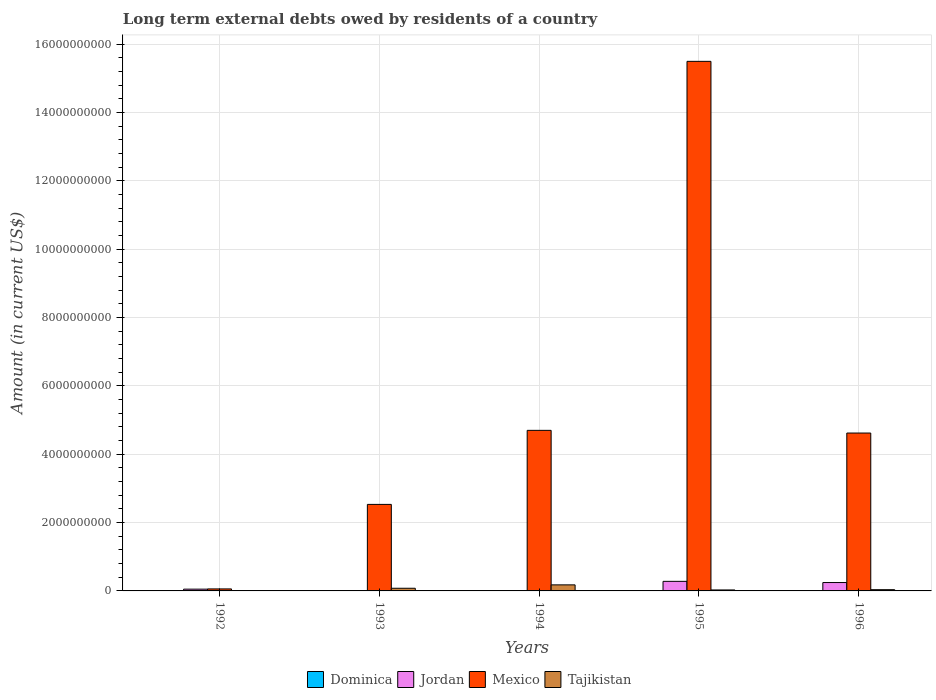Are the number of bars per tick equal to the number of legend labels?
Your answer should be compact. No. Are the number of bars on each tick of the X-axis equal?
Keep it short and to the point. No. How many bars are there on the 5th tick from the left?
Offer a very short reply. 4. How many bars are there on the 1st tick from the right?
Your answer should be very brief. 4. In how many cases, is the number of bars for a given year not equal to the number of legend labels?
Give a very brief answer. 2. What is the amount of long-term external debts owed by residents in Dominica in 1993?
Your response must be concise. 1.93e+06. Across all years, what is the maximum amount of long-term external debts owed by residents in Jordan?
Give a very brief answer. 2.80e+08. Across all years, what is the minimum amount of long-term external debts owed by residents in Jordan?
Provide a short and direct response. 0. In which year was the amount of long-term external debts owed by residents in Tajikistan maximum?
Give a very brief answer. 1994. What is the total amount of long-term external debts owed by residents in Tajikistan in the graph?
Offer a terse response. 3.30e+08. What is the difference between the amount of long-term external debts owed by residents in Dominica in 1992 and that in 1993?
Your response must be concise. 3.82e+06. What is the difference between the amount of long-term external debts owed by residents in Mexico in 1994 and the amount of long-term external debts owed by residents in Jordan in 1995?
Ensure brevity in your answer.  4.42e+09. What is the average amount of long-term external debts owed by residents in Dominica per year?
Provide a succinct answer. 3.55e+06. In the year 1992, what is the difference between the amount of long-term external debts owed by residents in Tajikistan and amount of long-term external debts owed by residents in Jordan?
Provide a short and direct response. -4.21e+07. In how many years, is the amount of long-term external debts owed by residents in Dominica greater than 10800000000 US$?
Offer a terse response. 0. What is the ratio of the amount of long-term external debts owed by residents in Dominica in 1993 to that in 1996?
Your answer should be very brief. 0.45. Is the amount of long-term external debts owed by residents in Tajikistan in 1994 less than that in 1996?
Offer a terse response. No. What is the difference between the highest and the second highest amount of long-term external debts owed by residents in Jordan?
Provide a short and direct response. 3.48e+07. What is the difference between the highest and the lowest amount of long-term external debts owed by residents in Mexico?
Make the answer very short. 1.54e+1. Is it the case that in every year, the sum of the amount of long-term external debts owed by residents in Tajikistan and amount of long-term external debts owed by residents in Mexico is greater than the sum of amount of long-term external debts owed by residents in Jordan and amount of long-term external debts owed by residents in Dominica?
Keep it short and to the point. No. Is it the case that in every year, the sum of the amount of long-term external debts owed by residents in Jordan and amount of long-term external debts owed by residents in Tajikistan is greater than the amount of long-term external debts owed by residents in Mexico?
Offer a terse response. No. How many bars are there?
Your answer should be compact. 17. Are the values on the major ticks of Y-axis written in scientific E-notation?
Make the answer very short. No. Does the graph contain any zero values?
Ensure brevity in your answer.  Yes. Where does the legend appear in the graph?
Provide a succinct answer. Bottom center. How many legend labels are there?
Your response must be concise. 4. What is the title of the graph?
Your response must be concise. Long term external debts owed by residents of a country. Does "United Kingdom" appear as one of the legend labels in the graph?
Offer a very short reply. No. What is the label or title of the Y-axis?
Ensure brevity in your answer.  Amount (in current US$). What is the Amount (in current US$) of Dominica in 1992?
Your answer should be compact. 5.75e+06. What is the Amount (in current US$) of Jordan in 1992?
Offer a terse response. 5.19e+07. What is the Amount (in current US$) of Mexico in 1992?
Offer a very short reply. 5.86e+07. What is the Amount (in current US$) of Tajikistan in 1992?
Give a very brief answer. 9.73e+06. What is the Amount (in current US$) of Dominica in 1993?
Keep it short and to the point. 1.93e+06. What is the Amount (in current US$) of Jordan in 1993?
Your answer should be very brief. 0. What is the Amount (in current US$) of Mexico in 1993?
Keep it short and to the point. 2.53e+09. What is the Amount (in current US$) of Tajikistan in 1993?
Give a very brief answer. 7.82e+07. What is the Amount (in current US$) of Dominica in 1994?
Keep it short and to the point. 0. What is the Amount (in current US$) in Jordan in 1994?
Make the answer very short. 0. What is the Amount (in current US$) of Mexico in 1994?
Offer a very short reply. 4.70e+09. What is the Amount (in current US$) in Tajikistan in 1994?
Provide a short and direct response. 1.77e+08. What is the Amount (in current US$) of Dominica in 1995?
Make the answer very short. 5.77e+06. What is the Amount (in current US$) in Jordan in 1995?
Provide a succinct answer. 2.80e+08. What is the Amount (in current US$) of Mexico in 1995?
Offer a terse response. 1.55e+1. What is the Amount (in current US$) in Tajikistan in 1995?
Your response must be concise. 2.84e+07. What is the Amount (in current US$) of Dominica in 1996?
Make the answer very short. 4.31e+06. What is the Amount (in current US$) of Jordan in 1996?
Give a very brief answer. 2.45e+08. What is the Amount (in current US$) of Mexico in 1996?
Ensure brevity in your answer.  4.62e+09. What is the Amount (in current US$) in Tajikistan in 1996?
Your answer should be compact. 3.65e+07. Across all years, what is the maximum Amount (in current US$) in Dominica?
Offer a terse response. 5.77e+06. Across all years, what is the maximum Amount (in current US$) of Jordan?
Ensure brevity in your answer.  2.80e+08. Across all years, what is the maximum Amount (in current US$) of Mexico?
Offer a terse response. 1.55e+1. Across all years, what is the maximum Amount (in current US$) of Tajikistan?
Make the answer very short. 1.77e+08. Across all years, what is the minimum Amount (in current US$) of Mexico?
Offer a terse response. 5.86e+07. Across all years, what is the minimum Amount (in current US$) in Tajikistan?
Offer a terse response. 9.73e+06. What is the total Amount (in current US$) in Dominica in the graph?
Your response must be concise. 1.78e+07. What is the total Amount (in current US$) in Jordan in the graph?
Give a very brief answer. 5.78e+08. What is the total Amount (in current US$) in Mexico in the graph?
Your answer should be compact. 2.74e+1. What is the total Amount (in current US$) of Tajikistan in the graph?
Ensure brevity in your answer.  3.30e+08. What is the difference between the Amount (in current US$) in Dominica in 1992 and that in 1993?
Provide a succinct answer. 3.82e+06. What is the difference between the Amount (in current US$) of Mexico in 1992 and that in 1993?
Offer a terse response. -2.47e+09. What is the difference between the Amount (in current US$) in Tajikistan in 1992 and that in 1993?
Ensure brevity in your answer.  -6.84e+07. What is the difference between the Amount (in current US$) of Mexico in 1992 and that in 1994?
Your answer should be very brief. -4.64e+09. What is the difference between the Amount (in current US$) in Tajikistan in 1992 and that in 1994?
Provide a short and direct response. -1.67e+08. What is the difference between the Amount (in current US$) of Dominica in 1992 and that in 1995?
Make the answer very short. -1.50e+04. What is the difference between the Amount (in current US$) of Jordan in 1992 and that in 1995?
Your answer should be compact. -2.28e+08. What is the difference between the Amount (in current US$) of Mexico in 1992 and that in 1995?
Offer a terse response. -1.54e+1. What is the difference between the Amount (in current US$) of Tajikistan in 1992 and that in 1995?
Provide a succinct answer. -1.86e+07. What is the difference between the Amount (in current US$) of Dominica in 1992 and that in 1996?
Make the answer very short. 1.44e+06. What is the difference between the Amount (in current US$) of Jordan in 1992 and that in 1996?
Keep it short and to the point. -1.94e+08. What is the difference between the Amount (in current US$) in Mexico in 1992 and that in 1996?
Your response must be concise. -4.56e+09. What is the difference between the Amount (in current US$) of Tajikistan in 1992 and that in 1996?
Ensure brevity in your answer.  -2.68e+07. What is the difference between the Amount (in current US$) in Mexico in 1993 and that in 1994?
Your answer should be compact. -2.17e+09. What is the difference between the Amount (in current US$) in Tajikistan in 1993 and that in 1994?
Give a very brief answer. -9.89e+07. What is the difference between the Amount (in current US$) in Dominica in 1993 and that in 1995?
Provide a succinct answer. -3.84e+06. What is the difference between the Amount (in current US$) of Mexico in 1993 and that in 1995?
Ensure brevity in your answer.  -1.30e+1. What is the difference between the Amount (in current US$) in Tajikistan in 1993 and that in 1995?
Provide a short and direct response. 4.98e+07. What is the difference between the Amount (in current US$) in Dominica in 1993 and that in 1996?
Provide a short and direct response. -2.38e+06. What is the difference between the Amount (in current US$) in Mexico in 1993 and that in 1996?
Give a very brief answer. -2.09e+09. What is the difference between the Amount (in current US$) of Tajikistan in 1993 and that in 1996?
Offer a terse response. 4.17e+07. What is the difference between the Amount (in current US$) of Mexico in 1994 and that in 1995?
Provide a short and direct response. -1.08e+1. What is the difference between the Amount (in current US$) in Tajikistan in 1994 and that in 1995?
Make the answer very short. 1.49e+08. What is the difference between the Amount (in current US$) of Mexico in 1994 and that in 1996?
Offer a terse response. 7.86e+07. What is the difference between the Amount (in current US$) of Tajikistan in 1994 and that in 1996?
Give a very brief answer. 1.41e+08. What is the difference between the Amount (in current US$) in Dominica in 1995 and that in 1996?
Keep it short and to the point. 1.46e+06. What is the difference between the Amount (in current US$) in Jordan in 1995 and that in 1996?
Give a very brief answer. 3.48e+07. What is the difference between the Amount (in current US$) in Mexico in 1995 and that in 1996?
Ensure brevity in your answer.  1.09e+1. What is the difference between the Amount (in current US$) of Tajikistan in 1995 and that in 1996?
Your answer should be compact. -8.11e+06. What is the difference between the Amount (in current US$) of Dominica in 1992 and the Amount (in current US$) of Mexico in 1993?
Provide a succinct answer. -2.53e+09. What is the difference between the Amount (in current US$) in Dominica in 1992 and the Amount (in current US$) in Tajikistan in 1993?
Offer a very short reply. -7.24e+07. What is the difference between the Amount (in current US$) in Jordan in 1992 and the Amount (in current US$) in Mexico in 1993?
Provide a succinct answer. -2.48e+09. What is the difference between the Amount (in current US$) in Jordan in 1992 and the Amount (in current US$) in Tajikistan in 1993?
Provide a short and direct response. -2.63e+07. What is the difference between the Amount (in current US$) of Mexico in 1992 and the Amount (in current US$) of Tajikistan in 1993?
Keep it short and to the point. -1.96e+07. What is the difference between the Amount (in current US$) of Dominica in 1992 and the Amount (in current US$) of Mexico in 1994?
Provide a short and direct response. -4.69e+09. What is the difference between the Amount (in current US$) of Dominica in 1992 and the Amount (in current US$) of Tajikistan in 1994?
Your response must be concise. -1.71e+08. What is the difference between the Amount (in current US$) of Jordan in 1992 and the Amount (in current US$) of Mexico in 1994?
Provide a short and direct response. -4.65e+09. What is the difference between the Amount (in current US$) of Jordan in 1992 and the Amount (in current US$) of Tajikistan in 1994?
Offer a very short reply. -1.25e+08. What is the difference between the Amount (in current US$) of Mexico in 1992 and the Amount (in current US$) of Tajikistan in 1994?
Give a very brief answer. -1.19e+08. What is the difference between the Amount (in current US$) in Dominica in 1992 and the Amount (in current US$) in Jordan in 1995?
Keep it short and to the point. -2.75e+08. What is the difference between the Amount (in current US$) in Dominica in 1992 and the Amount (in current US$) in Mexico in 1995?
Provide a succinct answer. -1.55e+1. What is the difference between the Amount (in current US$) of Dominica in 1992 and the Amount (in current US$) of Tajikistan in 1995?
Give a very brief answer. -2.26e+07. What is the difference between the Amount (in current US$) of Jordan in 1992 and the Amount (in current US$) of Mexico in 1995?
Offer a very short reply. -1.54e+1. What is the difference between the Amount (in current US$) in Jordan in 1992 and the Amount (in current US$) in Tajikistan in 1995?
Your answer should be compact. 2.35e+07. What is the difference between the Amount (in current US$) of Mexico in 1992 and the Amount (in current US$) of Tajikistan in 1995?
Your response must be concise. 3.02e+07. What is the difference between the Amount (in current US$) in Dominica in 1992 and the Amount (in current US$) in Jordan in 1996?
Make the answer very short. -2.40e+08. What is the difference between the Amount (in current US$) in Dominica in 1992 and the Amount (in current US$) in Mexico in 1996?
Offer a terse response. -4.61e+09. What is the difference between the Amount (in current US$) in Dominica in 1992 and the Amount (in current US$) in Tajikistan in 1996?
Keep it short and to the point. -3.07e+07. What is the difference between the Amount (in current US$) of Jordan in 1992 and the Amount (in current US$) of Mexico in 1996?
Ensure brevity in your answer.  -4.57e+09. What is the difference between the Amount (in current US$) in Jordan in 1992 and the Amount (in current US$) in Tajikistan in 1996?
Keep it short and to the point. 1.54e+07. What is the difference between the Amount (in current US$) in Mexico in 1992 and the Amount (in current US$) in Tajikistan in 1996?
Keep it short and to the point. 2.21e+07. What is the difference between the Amount (in current US$) of Dominica in 1993 and the Amount (in current US$) of Mexico in 1994?
Your answer should be compact. -4.70e+09. What is the difference between the Amount (in current US$) of Dominica in 1993 and the Amount (in current US$) of Tajikistan in 1994?
Offer a very short reply. -1.75e+08. What is the difference between the Amount (in current US$) of Mexico in 1993 and the Amount (in current US$) of Tajikistan in 1994?
Your response must be concise. 2.36e+09. What is the difference between the Amount (in current US$) in Dominica in 1993 and the Amount (in current US$) in Jordan in 1995?
Provide a succinct answer. -2.78e+08. What is the difference between the Amount (in current US$) in Dominica in 1993 and the Amount (in current US$) in Mexico in 1995?
Offer a terse response. -1.55e+1. What is the difference between the Amount (in current US$) in Dominica in 1993 and the Amount (in current US$) in Tajikistan in 1995?
Provide a short and direct response. -2.64e+07. What is the difference between the Amount (in current US$) in Mexico in 1993 and the Amount (in current US$) in Tajikistan in 1995?
Provide a succinct answer. 2.50e+09. What is the difference between the Amount (in current US$) in Dominica in 1993 and the Amount (in current US$) in Jordan in 1996?
Give a very brief answer. -2.44e+08. What is the difference between the Amount (in current US$) of Dominica in 1993 and the Amount (in current US$) of Mexico in 1996?
Provide a succinct answer. -4.62e+09. What is the difference between the Amount (in current US$) in Dominica in 1993 and the Amount (in current US$) in Tajikistan in 1996?
Offer a terse response. -3.46e+07. What is the difference between the Amount (in current US$) in Mexico in 1993 and the Amount (in current US$) in Tajikistan in 1996?
Your answer should be very brief. 2.50e+09. What is the difference between the Amount (in current US$) of Mexico in 1994 and the Amount (in current US$) of Tajikistan in 1995?
Your response must be concise. 4.67e+09. What is the difference between the Amount (in current US$) of Mexico in 1994 and the Amount (in current US$) of Tajikistan in 1996?
Ensure brevity in your answer.  4.66e+09. What is the difference between the Amount (in current US$) in Dominica in 1995 and the Amount (in current US$) in Jordan in 1996?
Provide a short and direct response. -2.40e+08. What is the difference between the Amount (in current US$) of Dominica in 1995 and the Amount (in current US$) of Mexico in 1996?
Keep it short and to the point. -4.61e+09. What is the difference between the Amount (in current US$) in Dominica in 1995 and the Amount (in current US$) in Tajikistan in 1996?
Ensure brevity in your answer.  -3.07e+07. What is the difference between the Amount (in current US$) in Jordan in 1995 and the Amount (in current US$) in Mexico in 1996?
Make the answer very short. -4.34e+09. What is the difference between the Amount (in current US$) in Jordan in 1995 and the Amount (in current US$) in Tajikistan in 1996?
Offer a very short reply. 2.44e+08. What is the difference between the Amount (in current US$) in Mexico in 1995 and the Amount (in current US$) in Tajikistan in 1996?
Keep it short and to the point. 1.55e+1. What is the average Amount (in current US$) in Dominica per year?
Make the answer very short. 3.55e+06. What is the average Amount (in current US$) of Jordan per year?
Ensure brevity in your answer.  1.16e+08. What is the average Amount (in current US$) of Mexico per year?
Provide a short and direct response. 5.48e+09. What is the average Amount (in current US$) of Tajikistan per year?
Offer a terse response. 6.60e+07. In the year 1992, what is the difference between the Amount (in current US$) in Dominica and Amount (in current US$) in Jordan?
Keep it short and to the point. -4.61e+07. In the year 1992, what is the difference between the Amount (in current US$) of Dominica and Amount (in current US$) of Mexico?
Keep it short and to the point. -5.28e+07. In the year 1992, what is the difference between the Amount (in current US$) in Dominica and Amount (in current US$) in Tajikistan?
Provide a succinct answer. -3.98e+06. In the year 1992, what is the difference between the Amount (in current US$) in Jordan and Amount (in current US$) in Mexico?
Your response must be concise. -6.70e+06. In the year 1992, what is the difference between the Amount (in current US$) of Jordan and Amount (in current US$) of Tajikistan?
Give a very brief answer. 4.21e+07. In the year 1992, what is the difference between the Amount (in current US$) of Mexico and Amount (in current US$) of Tajikistan?
Offer a very short reply. 4.88e+07. In the year 1993, what is the difference between the Amount (in current US$) of Dominica and Amount (in current US$) of Mexico?
Make the answer very short. -2.53e+09. In the year 1993, what is the difference between the Amount (in current US$) in Dominica and Amount (in current US$) in Tajikistan?
Your response must be concise. -7.62e+07. In the year 1993, what is the difference between the Amount (in current US$) of Mexico and Amount (in current US$) of Tajikistan?
Provide a succinct answer. 2.45e+09. In the year 1994, what is the difference between the Amount (in current US$) in Mexico and Amount (in current US$) in Tajikistan?
Ensure brevity in your answer.  4.52e+09. In the year 1995, what is the difference between the Amount (in current US$) of Dominica and Amount (in current US$) of Jordan?
Your answer should be very brief. -2.74e+08. In the year 1995, what is the difference between the Amount (in current US$) of Dominica and Amount (in current US$) of Mexico?
Ensure brevity in your answer.  -1.55e+1. In the year 1995, what is the difference between the Amount (in current US$) in Dominica and Amount (in current US$) in Tajikistan?
Offer a terse response. -2.26e+07. In the year 1995, what is the difference between the Amount (in current US$) in Jordan and Amount (in current US$) in Mexico?
Provide a short and direct response. -1.52e+1. In the year 1995, what is the difference between the Amount (in current US$) in Jordan and Amount (in current US$) in Tajikistan?
Your response must be concise. 2.52e+08. In the year 1995, what is the difference between the Amount (in current US$) of Mexico and Amount (in current US$) of Tajikistan?
Your response must be concise. 1.55e+1. In the year 1996, what is the difference between the Amount (in current US$) of Dominica and Amount (in current US$) of Jordan?
Provide a succinct answer. -2.41e+08. In the year 1996, what is the difference between the Amount (in current US$) of Dominica and Amount (in current US$) of Mexico?
Keep it short and to the point. -4.62e+09. In the year 1996, what is the difference between the Amount (in current US$) in Dominica and Amount (in current US$) in Tajikistan?
Your answer should be very brief. -3.22e+07. In the year 1996, what is the difference between the Amount (in current US$) of Jordan and Amount (in current US$) of Mexico?
Your answer should be compact. -4.38e+09. In the year 1996, what is the difference between the Amount (in current US$) in Jordan and Amount (in current US$) in Tajikistan?
Keep it short and to the point. 2.09e+08. In the year 1996, what is the difference between the Amount (in current US$) of Mexico and Amount (in current US$) of Tajikistan?
Provide a short and direct response. 4.58e+09. What is the ratio of the Amount (in current US$) in Dominica in 1992 to that in 1993?
Give a very brief answer. 2.98. What is the ratio of the Amount (in current US$) of Mexico in 1992 to that in 1993?
Provide a succinct answer. 0.02. What is the ratio of the Amount (in current US$) of Tajikistan in 1992 to that in 1993?
Give a very brief answer. 0.12. What is the ratio of the Amount (in current US$) of Mexico in 1992 to that in 1994?
Give a very brief answer. 0.01. What is the ratio of the Amount (in current US$) in Tajikistan in 1992 to that in 1994?
Provide a succinct answer. 0.05. What is the ratio of the Amount (in current US$) in Dominica in 1992 to that in 1995?
Provide a short and direct response. 1. What is the ratio of the Amount (in current US$) in Jordan in 1992 to that in 1995?
Offer a very short reply. 0.19. What is the ratio of the Amount (in current US$) in Mexico in 1992 to that in 1995?
Provide a short and direct response. 0. What is the ratio of the Amount (in current US$) in Tajikistan in 1992 to that in 1995?
Ensure brevity in your answer.  0.34. What is the ratio of the Amount (in current US$) in Dominica in 1992 to that in 1996?
Your answer should be compact. 1.33. What is the ratio of the Amount (in current US$) of Jordan in 1992 to that in 1996?
Offer a terse response. 0.21. What is the ratio of the Amount (in current US$) of Mexico in 1992 to that in 1996?
Make the answer very short. 0.01. What is the ratio of the Amount (in current US$) of Tajikistan in 1992 to that in 1996?
Your answer should be very brief. 0.27. What is the ratio of the Amount (in current US$) of Mexico in 1993 to that in 1994?
Offer a terse response. 0.54. What is the ratio of the Amount (in current US$) of Tajikistan in 1993 to that in 1994?
Give a very brief answer. 0.44. What is the ratio of the Amount (in current US$) of Dominica in 1993 to that in 1995?
Give a very brief answer. 0.33. What is the ratio of the Amount (in current US$) in Mexico in 1993 to that in 1995?
Provide a short and direct response. 0.16. What is the ratio of the Amount (in current US$) of Tajikistan in 1993 to that in 1995?
Offer a terse response. 2.75. What is the ratio of the Amount (in current US$) in Dominica in 1993 to that in 1996?
Provide a short and direct response. 0.45. What is the ratio of the Amount (in current US$) in Mexico in 1993 to that in 1996?
Your response must be concise. 0.55. What is the ratio of the Amount (in current US$) in Tajikistan in 1993 to that in 1996?
Your answer should be compact. 2.14. What is the ratio of the Amount (in current US$) in Mexico in 1994 to that in 1995?
Give a very brief answer. 0.3. What is the ratio of the Amount (in current US$) in Tajikistan in 1994 to that in 1995?
Keep it short and to the point. 6.24. What is the ratio of the Amount (in current US$) of Tajikistan in 1994 to that in 1996?
Offer a very short reply. 4.85. What is the ratio of the Amount (in current US$) of Dominica in 1995 to that in 1996?
Keep it short and to the point. 1.34. What is the ratio of the Amount (in current US$) in Jordan in 1995 to that in 1996?
Provide a short and direct response. 1.14. What is the ratio of the Amount (in current US$) of Mexico in 1995 to that in 1996?
Your response must be concise. 3.35. What is the ratio of the Amount (in current US$) of Tajikistan in 1995 to that in 1996?
Ensure brevity in your answer.  0.78. What is the difference between the highest and the second highest Amount (in current US$) of Dominica?
Offer a terse response. 1.50e+04. What is the difference between the highest and the second highest Amount (in current US$) of Jordan?
Ensure brevity in your answer.  3.48e+07. What is the difference between the highest and the second highest Amount (in current US$) in Mexico?
Make the answer very short. 1.08e+1. What is the difference between the highest and the second highest Amount (in current US$) in Tajikistan?
Offer a very short reply. 9.89e+07. What is the difference between the highest and the lowest Amount (in current US$) of Dominica?
Give a very brief answer. 5.77e+06. What is the difference between the highest and the lowest Amount (in current US$) in Jordan?
Provide a short and direct response. 2.80e+08. What is the difference between the highest and the lowest Amount (in current US$) of Mexico?
Your answer should be very brief. 1.54e+1. What is the difference between the highest and the lowest Amount (in current US$) in Tajikistan?
Provide a succinct answer. 1.67e+08. 